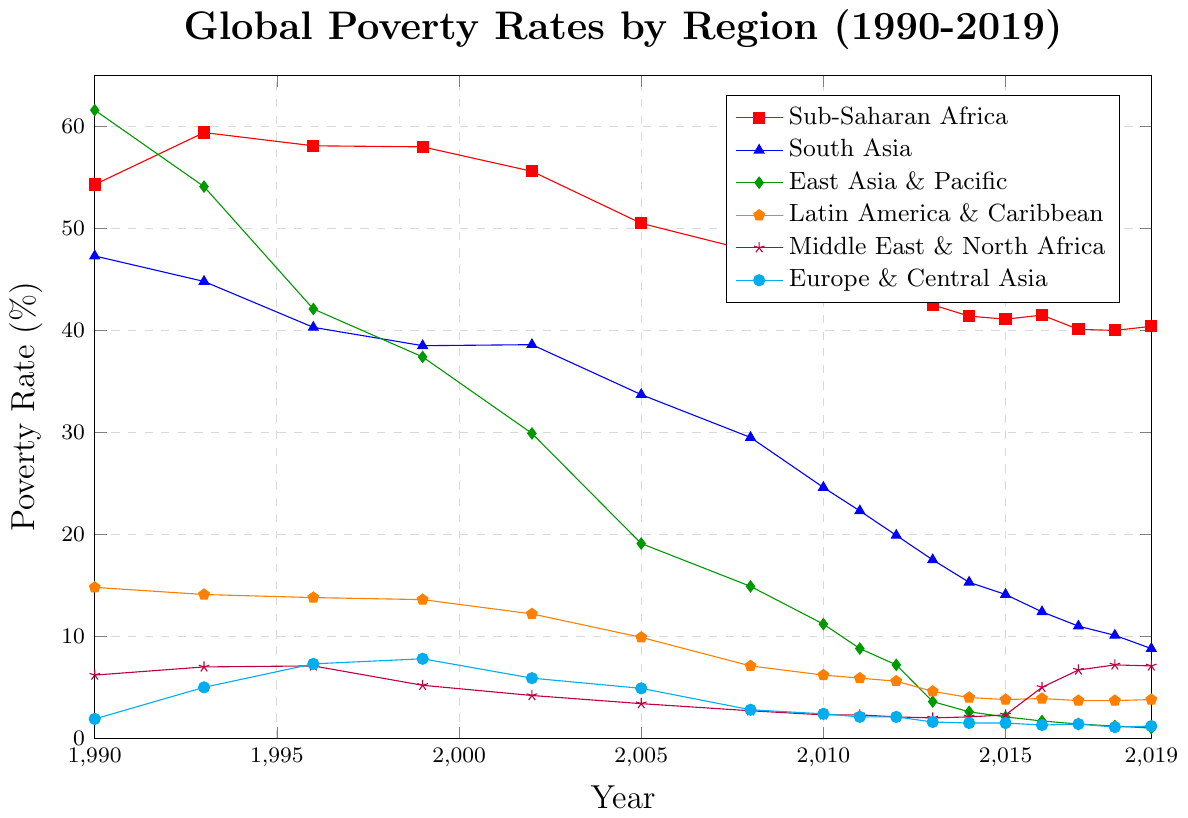Which region saw the greatest decrease in poverty rates from 1990 to 2019? Explanation: Observing the lines, note the starting and ending points for each region. Sub-Saharan Africa starts at 54.3% and ends at 40.4% (a reduction of 13.9%); South Asia starts at 47.3% and ends at 8.8% (a reduction of 38.5%); East Asia & Pacific starts at 61.6% and ends at 1.0% (a reduction of 60.6%); Latin America & Caribbean starts at 14.8% and ends at 3.8% (a reduction of 11%); Middle East & North Africa starts at 6.2% and ends at 7.1% (an increase of 0.9%); Europe & Central Asia starts at 1.9% and ends at 1.2% (a reduction of 0.7%). Thus, East Asia & Pacific saw the greatest reduction.
Answer: East Asia & Pacific Which region experienced an increase in poverty rates over any period shown? Explanation: Looking at the lines, note any rising trends. The Middle East & North Africa line increases from 2.1% in 2012 to 7.2% in 2018. Thus, the Middle East & North Africa experienced an increase in poverty rates during this period.
Answer: Middle East & North Africa What was the poverty rate trend in Europe & Central Asia from 1990 to 2019? Explanation: The line starts at 1.9% in 1990, rises to a peak of 7.8% in 1999, then declines and stabilizes around 1.1%-1.5% since 2013. The overall trend features an initial rise followed by a decreasing trend.
Answer: Initial rise followed by a decrease Which two regions had the closest poverty rates in 2019, and what were those rates? Explanation: Look at the end points on the graph for 2019. South Asia has 8.8%, Sub-Saharan Africa has 40.4%, East Asia & Pacific has 1.0%, Latin America & Caribbean has 3.8%, Middle East & North Africa has 7.1%, and Europe & Central Asia has 1.2%. The closest rates are East Asia & Pacific (1.0%) and Europe & Central Asia (1.2%).
Answer: East Asia & Pacific and Europe & Central Asia, 1.0% and 1.2% Between which consecutive years did Sub-Saharan Africa see the largest decrease in poverty rate, and what was the change? Explanation: Examine the Sub-Saharan Africa line for the steepest decline between consecutive data points. The largest drop occurs from 1999 to 2002, decreasing from 58.0% to 55.6%, a change of 2.4%.
Answer: Between 1999 and 2002, with a decrease of 2.4% In which year did Latin America & Caribbean see the poverty rate drop below 10%? Explanation: Follow the Latin America & Caribbean line to identify when it first falls below 10%. It drops from 12.2% in 2002 to 9.9% in 2005.
Answer: 2005 What is the average poverty rate for South Asia from 1990 to 2019? Explanation: Sum the poverty rates for South Asia over the years and divide by the number of years. The sum is (47.3 + 44.8 + 40.3 + 38.5 + 38.6 + 33.7 + 29.5 + 24.6 + 22.3 + 19.9 + 17.5 + 15.3 + 14.1 + 12.4 + 11.0 + 10.1 + 8.8) = 429.4. Divide by 17 years to get 429.4 / 17 ≈ 25.26%.
Answer: 25.26% Which region had the minimum poverty rate in 1999 and what was that rate? Explanation: Look for the lowest point on the graph for 1999. Europe & Central Asia had the lowest poverty rate in 1999 at 7.8%.
Answer: Europe & Central Asia, 7.8% What was the poverty rate trend in South Asia between 2015 and 2019? Explanation: Follow the South Asia line from 2015, where the rate was 14.1%, to 2016 (12.4%), 2017 (11.0%), 2018 (10.1%), and down to 8.8% in 2019. The trend shows a continuous decrease.
Answer: Continuous decrease 